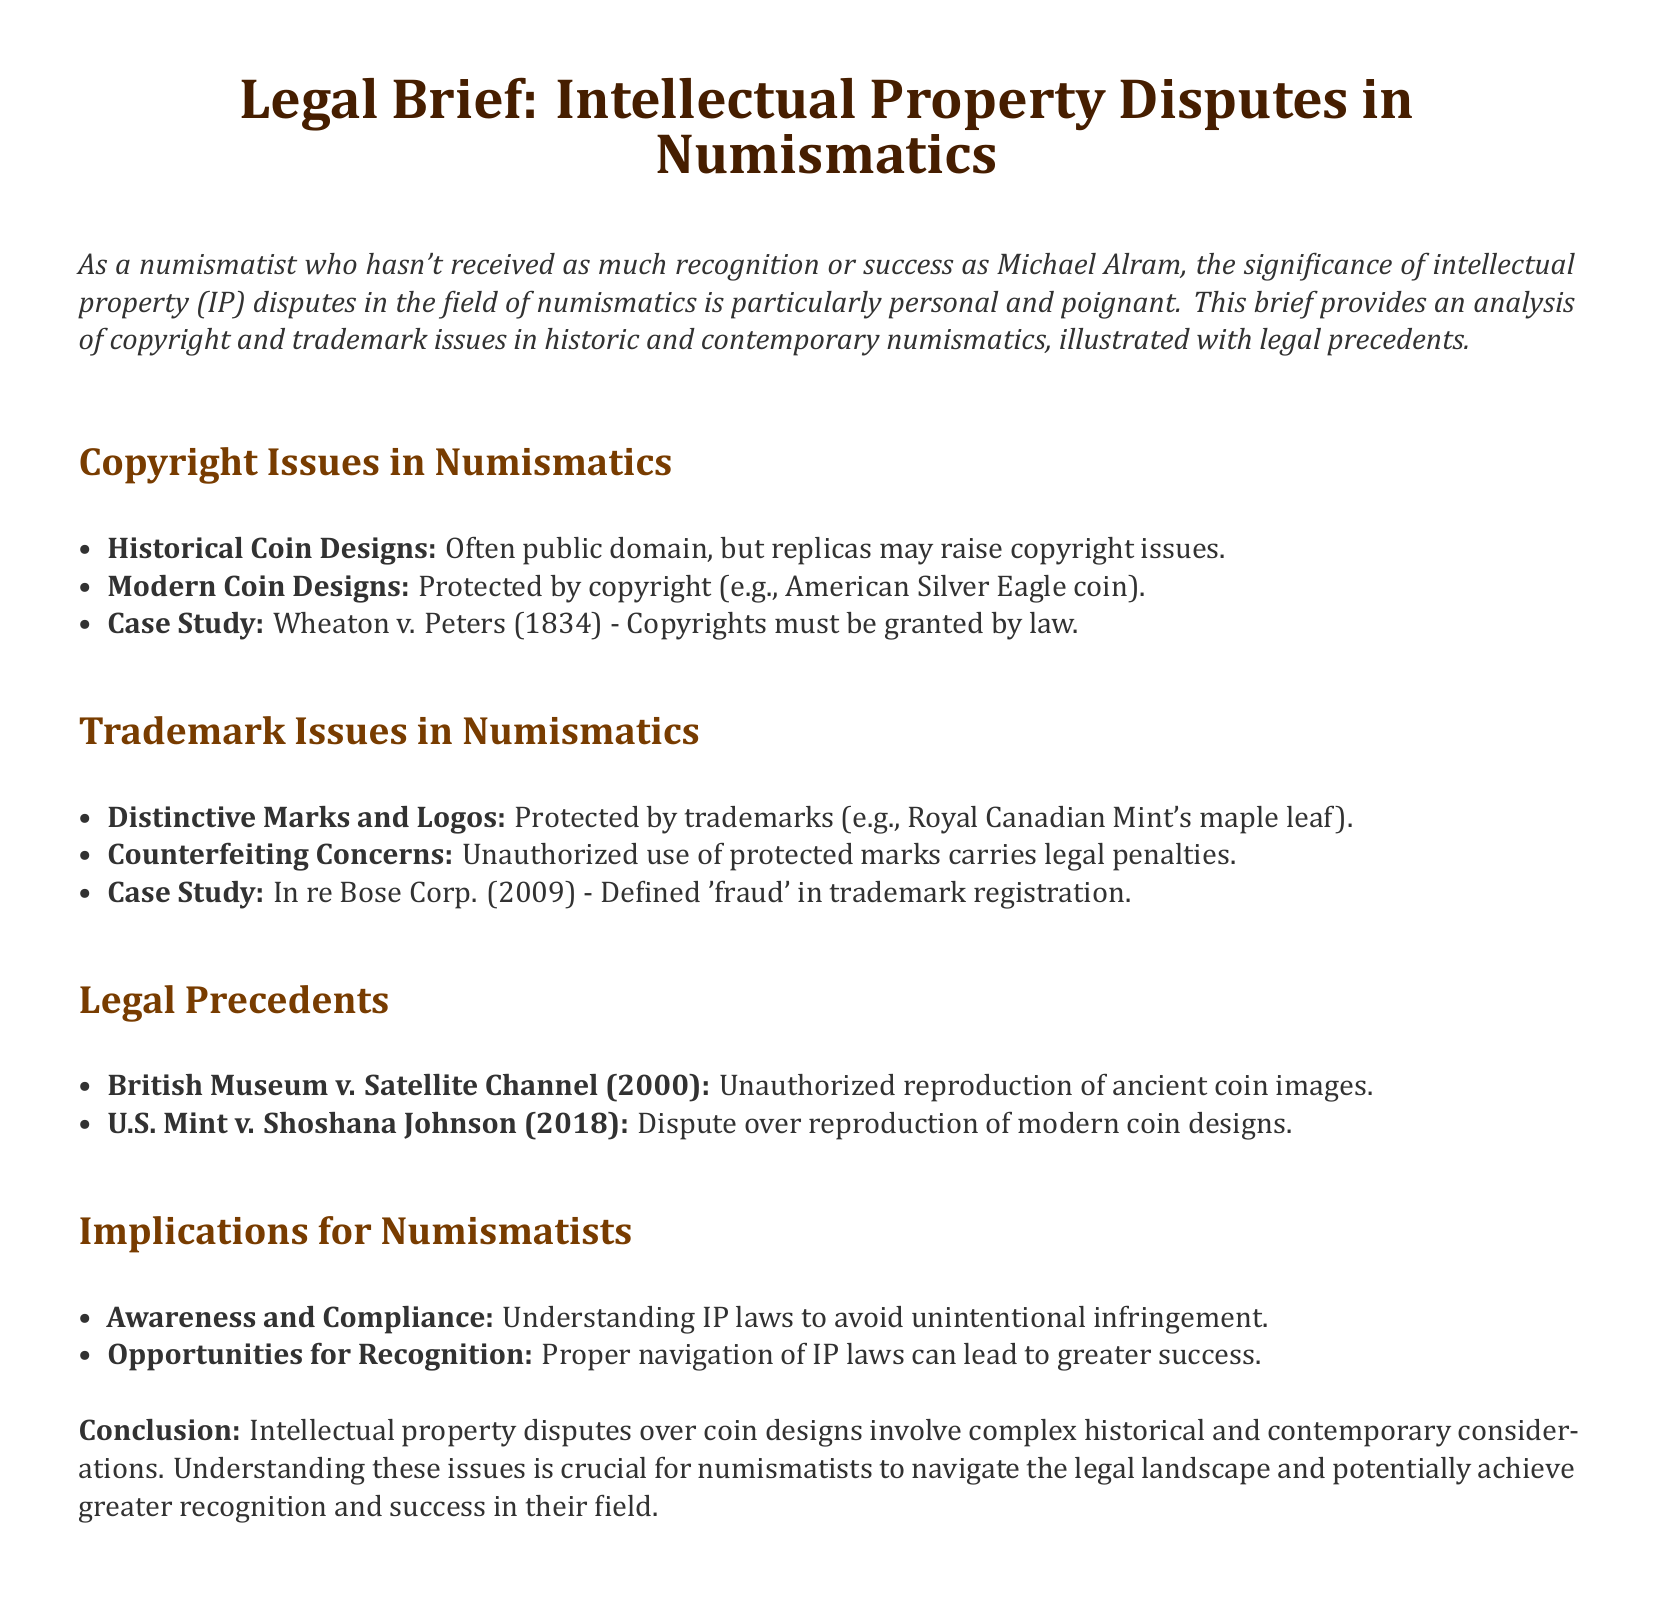What is the case study mentioned for copyright issues? The brief mentions "Wheaton v. Peters (1834)" as a case study concerning copyright issues.
Answer: Wheaton v. Peters (1834) What coin design is specifically mentioned as being protected by copyright? The document cites the "American Silver Eagle coin" as an example of a modern coin design protected by copyright.
Answer: American Silver Eagle coin What year was the case "In re Bose Corp." decided? The brief states that this case was decided in 2009, providing a specific year for a trademark issue.
Answer: 2009 Which organization is mentioned in relation to a distinctive trademark? The "Royal Canadian Mint" is noted for its distinct trademark in the context of coin designs.
Answer: Royal Canadian Mint What is a significant implication for numismatists mentioned in the brief? The document highlights "Understanding IP laws to avoid unintentional infringement" as a critical implication for numismatists.
Answer: Understanding IP laws Which legal precedent involved unauthorized reproduction of ancient coin images? The case "British Museum v. Satellite Channel (2000)" is noted for addressing the issue of unauthorized reproduction.
Answer: British Museum v. Satellite Channel (2000) What is the primary subject of the legal brief? The focus of the brief is on "Intellectual Property Disputes in Numismatics," outlining the issues related to IP in coin design.
Answer: Intellectual Property Disputes in Numismatics What important opportunity is highlighted for numismatists navigating IP laws? The brief states that "proper navigation of IP laws can lead to greater success" as an essential opportunity for numismatists.
Answer: Greater success Which historic aspect raises copyright issues according to the document? The brief suggests that "Historical Coin Designs" are often in public domain, raising specific copyright concerns for replicas.
Answer: Historical Coin Designs What case study addresses trademark issues involving modern coin designs? The document cites "U.S. Mint v. Shoshana Johnson (2018)" as a relevant case study for trademark issues related to modern coin designs.
Answer: U.S. Mint v. Shoshana Johnson (2018) 